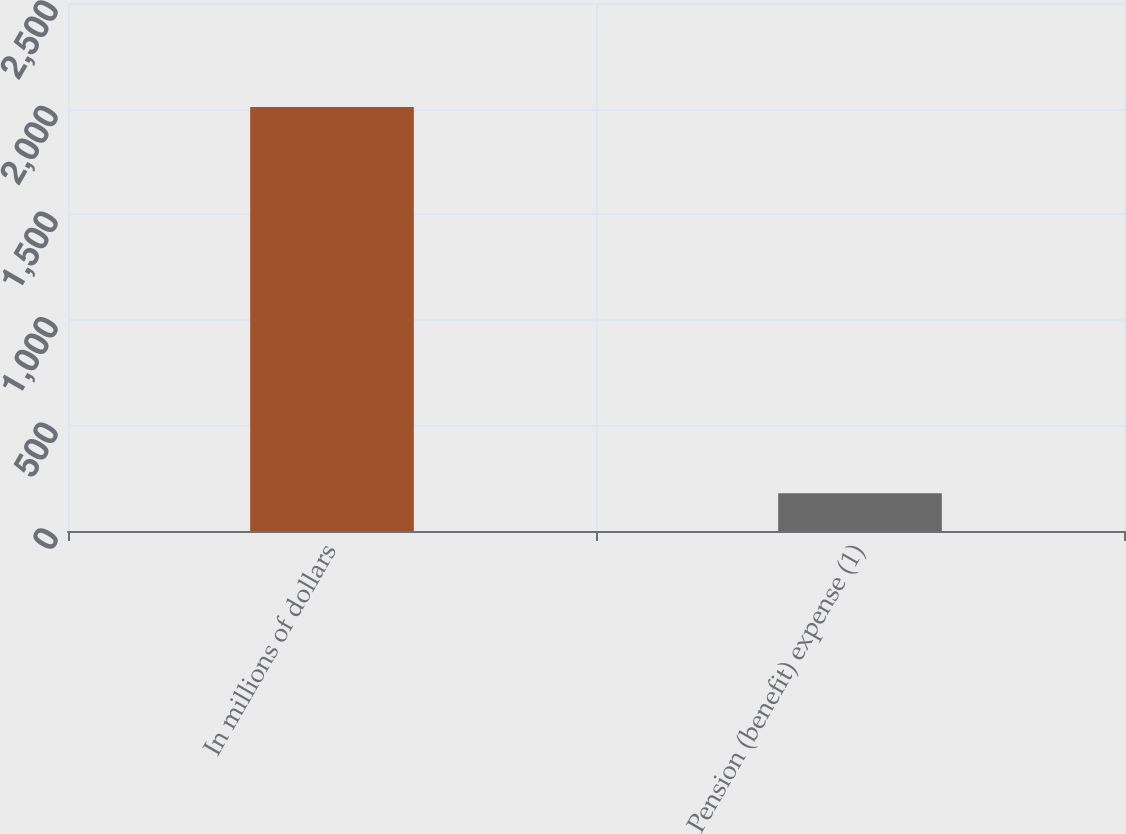Convert chart to OTSL. <chart><loc_0><loc_0><loc_500><loc_500><bar_chart><fcel>In millions of dollars<fcel>Pension (benefit) expense (1)<nl><fcel>2007<fcel>179<nl></chart> 